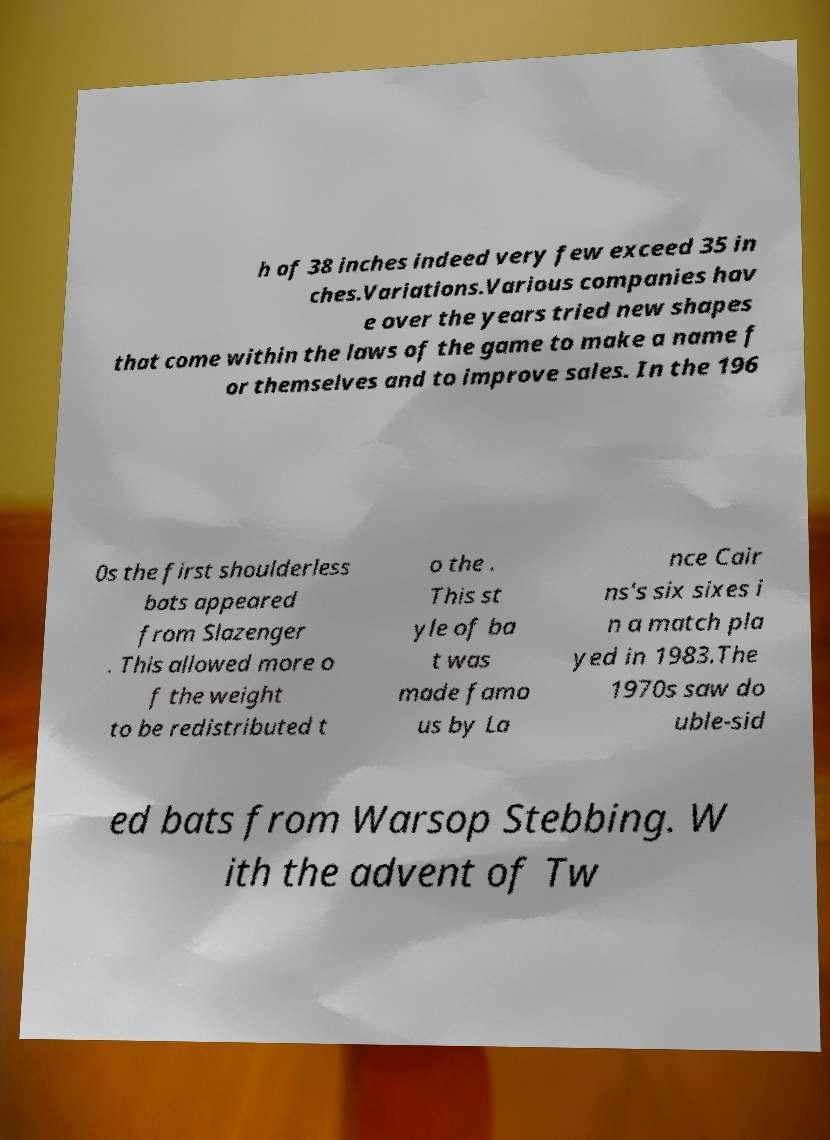Could you assist in decoding the text presented in this image and type it out clearly? h of 38 inches indeed very few exceed 35 in ches.Variations.Various companies hav e over the years tried new shapes that come within the laws of the game to make a name f or themselves and to improve sales. In the 196 0s the first shoulderless bats appeared from Slazenger . This allowed more o f the weight to be redistributed t o the . This st yle of ba t was made famo us by La nce Cair ns's six sixes i n a match pla yed in 1983.The 1970s saw do uble-sid ed bats from Warsop Stebbing. W ith the advent of Tw 